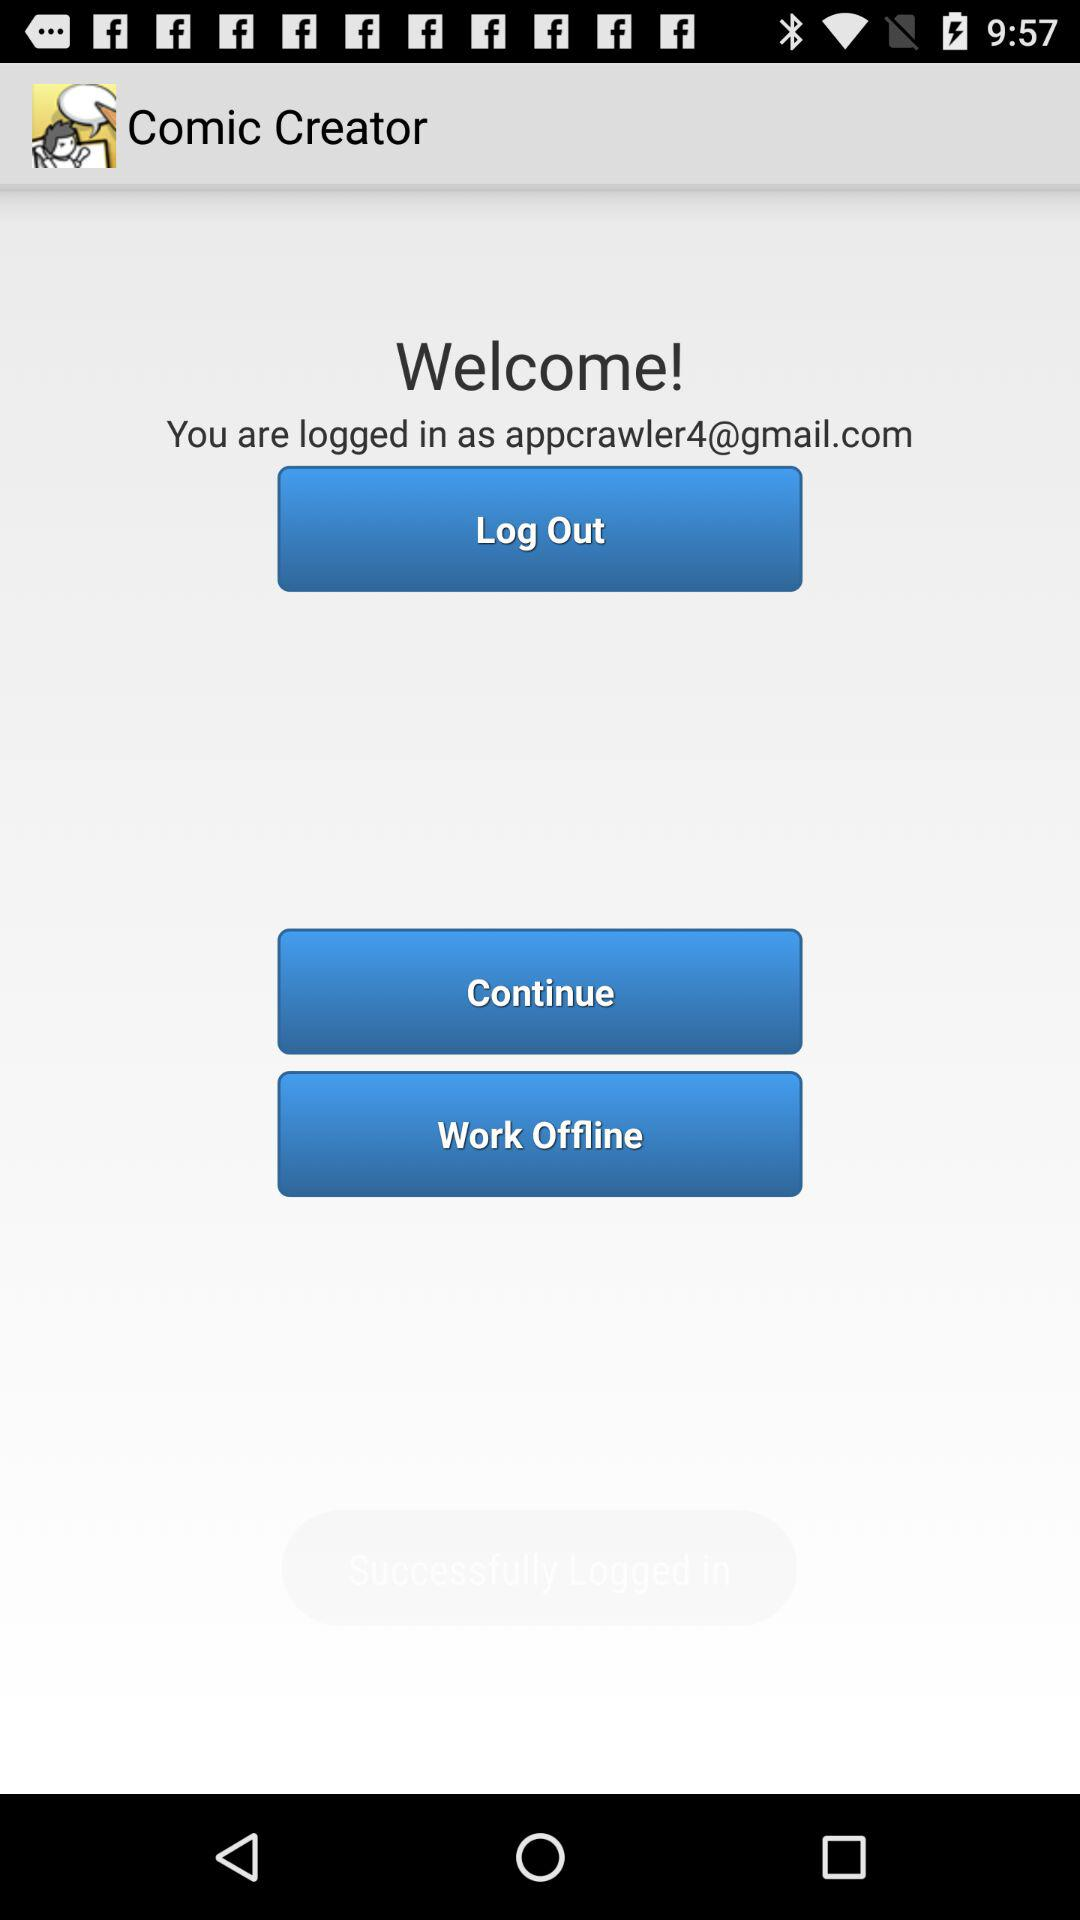What is the application name? The application name is "Comic Creator". 